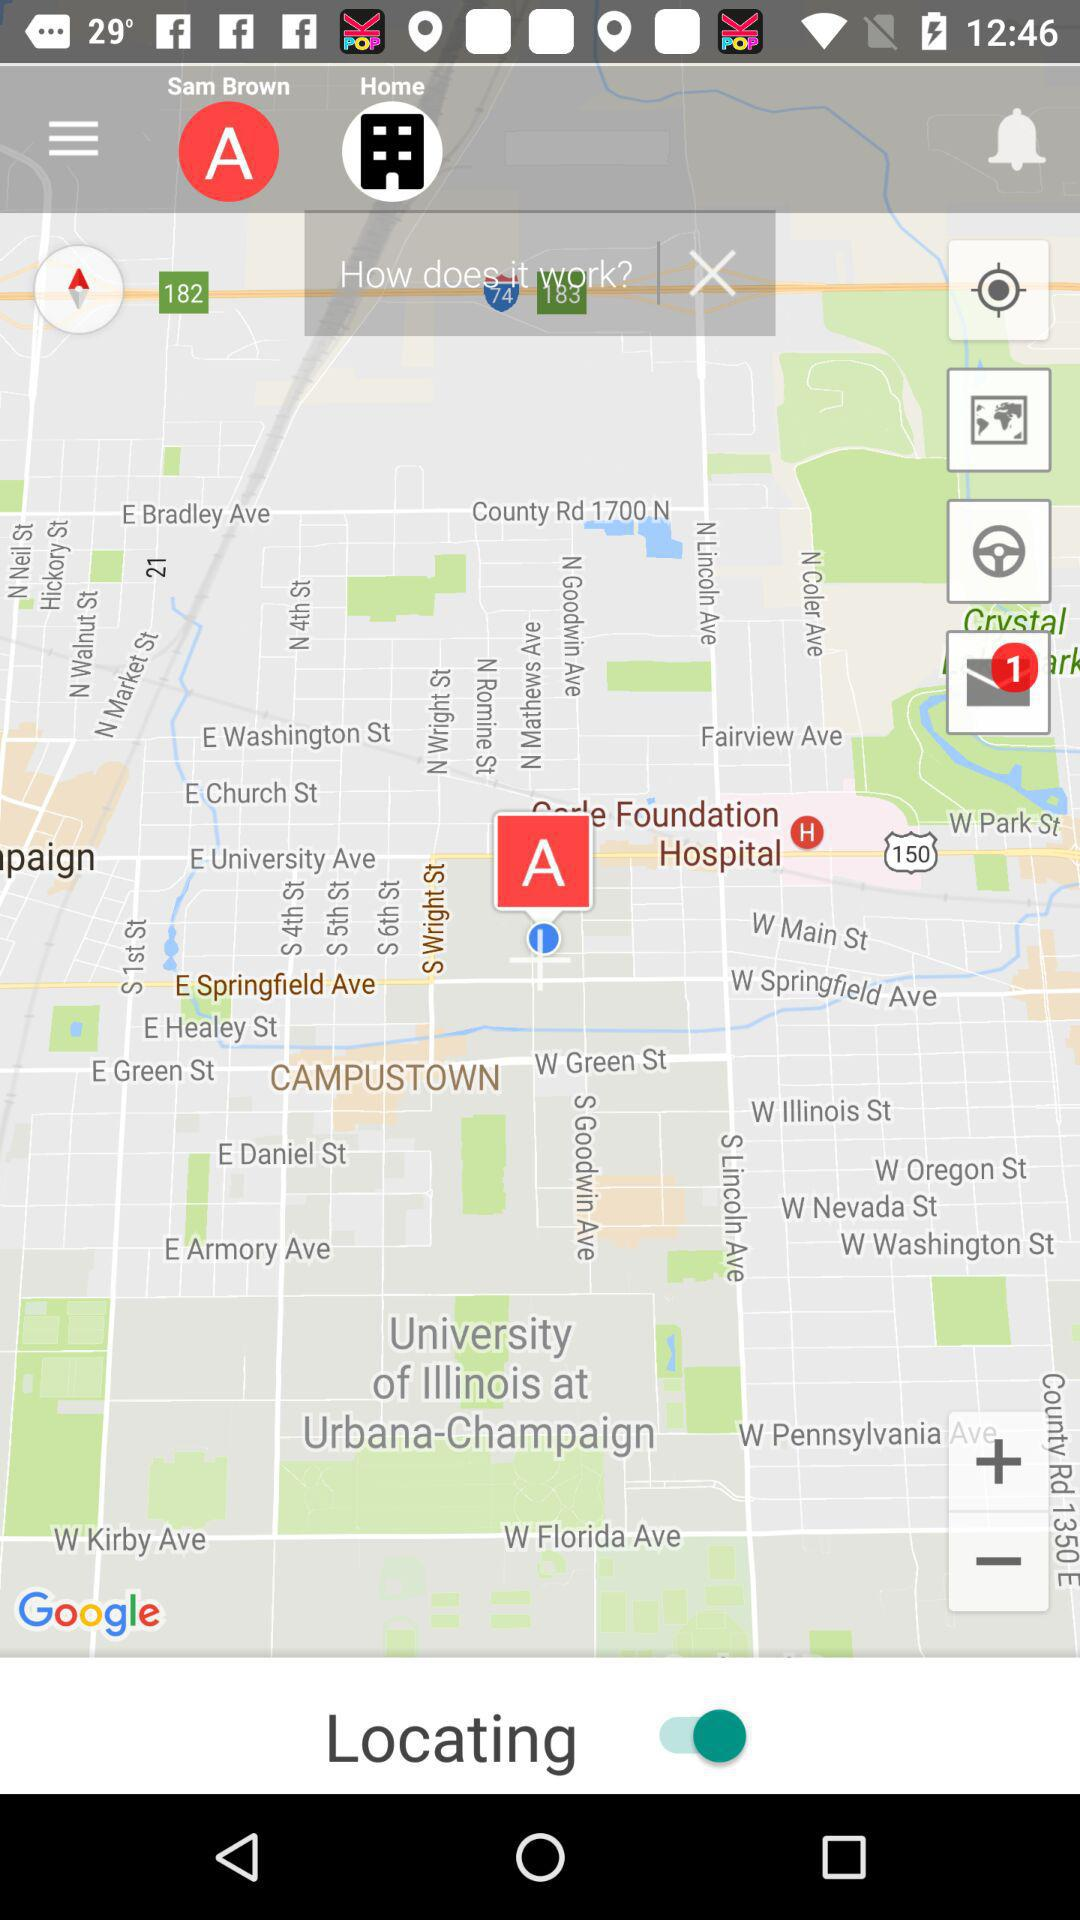What is the status of "Locating"? The status is "on". 